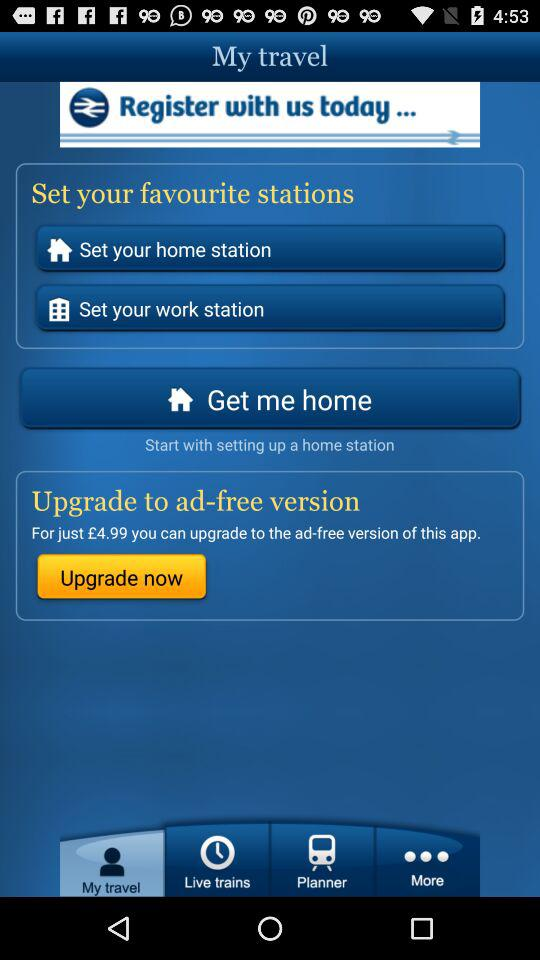What is the cost to upgrade to the ad-free version? The cost is £4.99. 